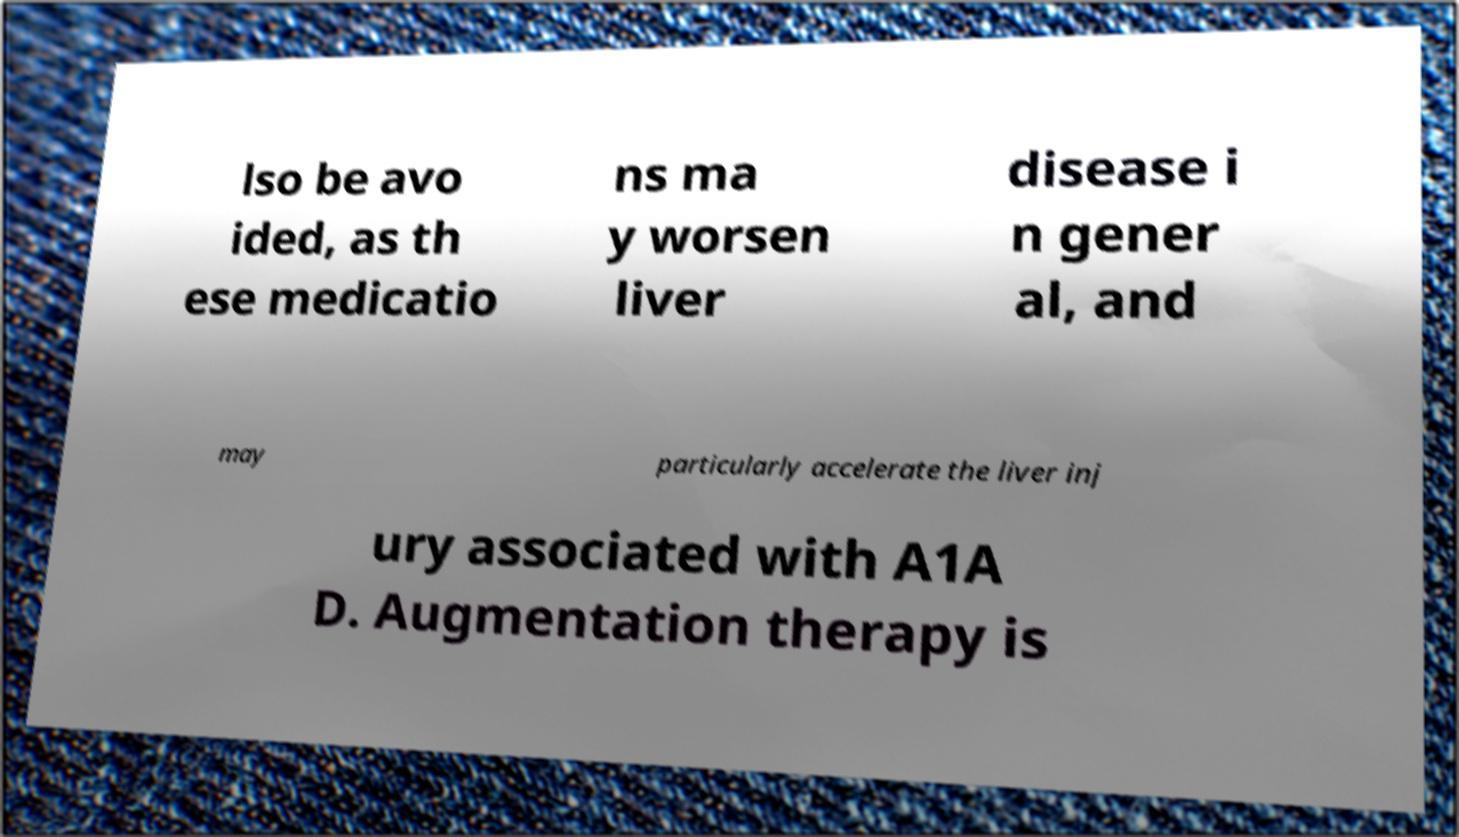I need the written content from this picture converted into text. Can you do that? lso be avo ided, as th ese medicatio ns ma y worsen liver disease i n gener al, and may particularly accelerate the liver inj ury associated with A1A D. Augmentation therapy is 